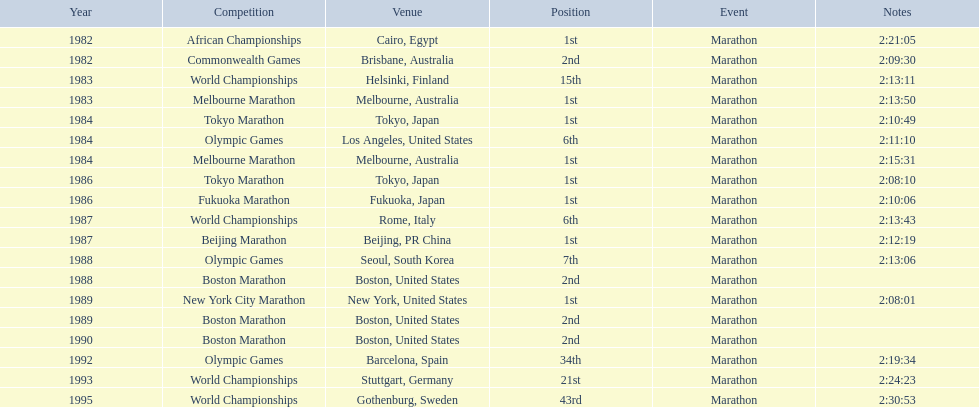What was the exclusive competition to transpire in china? Beijing Marathon. 